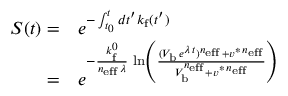Convert formula to latex. <formula><loc_0><loc_0><loc_500><loc_500>\begin{array} { r l } { S ( t ) = } & e ^ { - \int _ { t _ { 0 } } ^ { t } d t ^ { \prime } k _ { f } ( t ^ { \prime } ) } } \\ { = } & e ^ { - \frac { k _ { f } ^ { 0 } } { n _ { e f f } \, \lambda } \, \ln \left ( \frac { ( V _ { b } \, e ^ { \lambda \, t } ) ^ { n _ { e f f } } + v ^ { \ast \, n _ { e f f } } } { V _ { b } ^ { n _ { e f f } } + v ^ { \ast \, n _ { e f f } } } \right ) } } \end{array}</formula> 